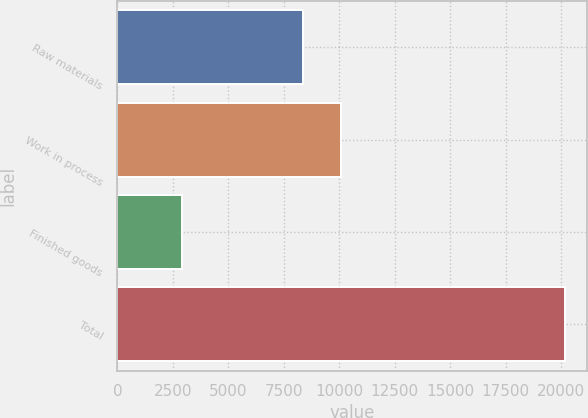Convert chart. <chart><loc_0><loc_0><loc_500><loc_500><bar_chart><fcel>Raw materials<fcel>Work in process<fcel>Finished goods<fcel>Total<nl><fcel>8365<fcel>10092.2<fcel>2897<fcel>20169<nl></chart> 